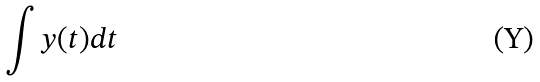Convert formula to latex. <formula><loc_0><loc_0><loc_500><loc_500>\int y ( t ) d t</formula> 